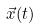<formula> <loc_0><loc_0><loc_500><loc_500>\vec { x } ( t )</formula> 